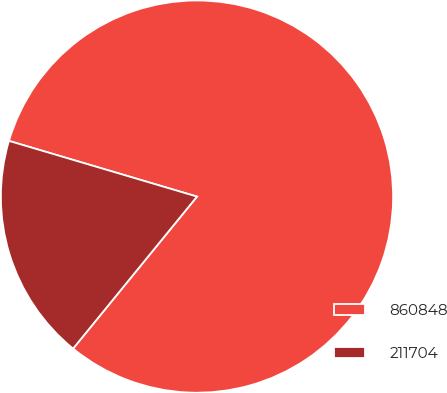Convert chart. <chart><loc_0><loc_0><loc_500><loc_500><pie_chart><fcel>860848<fcel>211704<nl><fcel>81.3%<fcel>18.7%<nl></chart> 